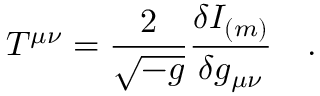<formula> <loc_0><loc_0><loc_500><loc_500>T ^ { \mu \nu } = { \frac { 2 } { \sqrt { - g } } } { \frac { \delta I _ { ( m ) } } { \delta g _ { \mu \nu } } } .</formula> 